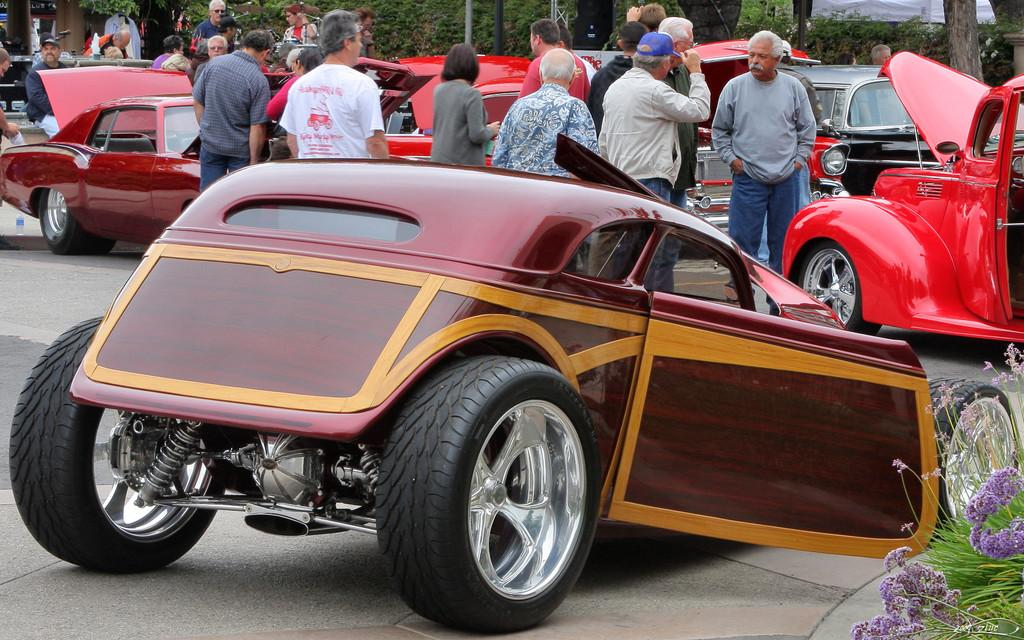What color is the car in the image? The car in the image is maroon-colored. Where is the car located in the image? The car is parked on a path. What is beside the car in the image? There is a plant beside the car. What can be seen in the background of the image? There are people, other cars, and trees in the background of the image. What type of knife is being used to cut the cream in the image? There is no knife or cream present in the image; it features a maroon-colored car parked on a path with a plant beside it and people, other cars, and trees in the background. 